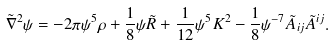<formula> <loc_0><loc_0><loc_500><loc_500>\tilde { \nabla } ^ { 2 } \psi = - 2 \pi \psi ^ { 5 } \rho + \frac { 1 } { 8 } \psi \tilde { R } + \frac { 1 } { 1 2 } \psi ^ { 5 } K ^ { 2 } - \frac { 1 } { 8 } \psi ^ { - 7 } \tilde { A } _ { i j } \tilde { A } ^ { i j } .</formula> 